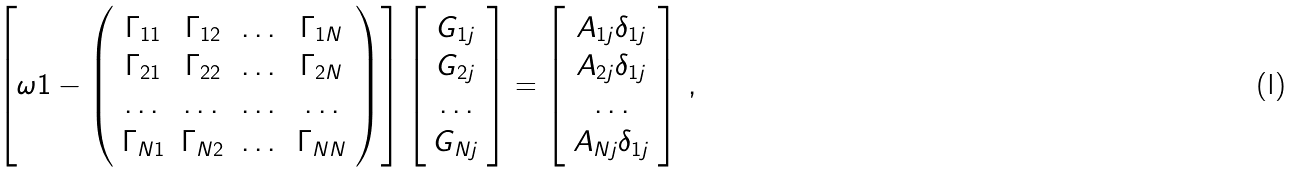<formula> <loc_0><loc_0><loc_500><loc_500>\left [ \omega { 1 } - \left ( \begin{array} { c c c c } { \Gamma } _ { 1 1 } & { \Gamma } _ { 1 2 } & \dots & { \Gamma } _ { 1 N } \\ { \Gamma } _ { 2 1 } & { \Gamma } _ { 2 2 } & \dots & { \Gamma } _ { 2 N } \\ \dots & \dots & \dots & \dots \\ { \Gamma } _ { N 1 } & { \Gamma } _ { N 2 } & \dots & { \Gamma } _ { N N } \end{array} \right ) \right ] \left [ \begin{array} { c } { G } _ { 1 j } \\ { G } _ { 2 j } \\ \dots \\ { G } _ { N j } \end{array} \right ] = \left [ \begin{array} { c } { A } _ { 1 j } \delta _ { 1 j } \\ { A } _ { 2 j } \delta _ { 1 j } \\ \dots \\ { A } _ { N j } \delta _ { 1 j } \end{array} \right ] \, ,</formula> 